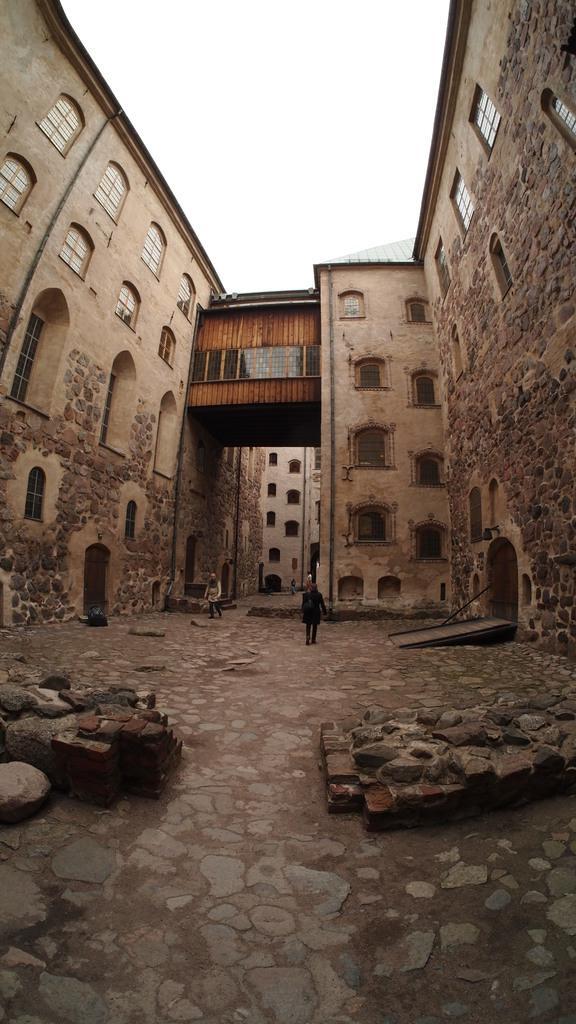Describe this image in one or two sentences. In this image, I can see the rocks and buildings with windows. There are two persons standing. In the background, I can see the sky. 